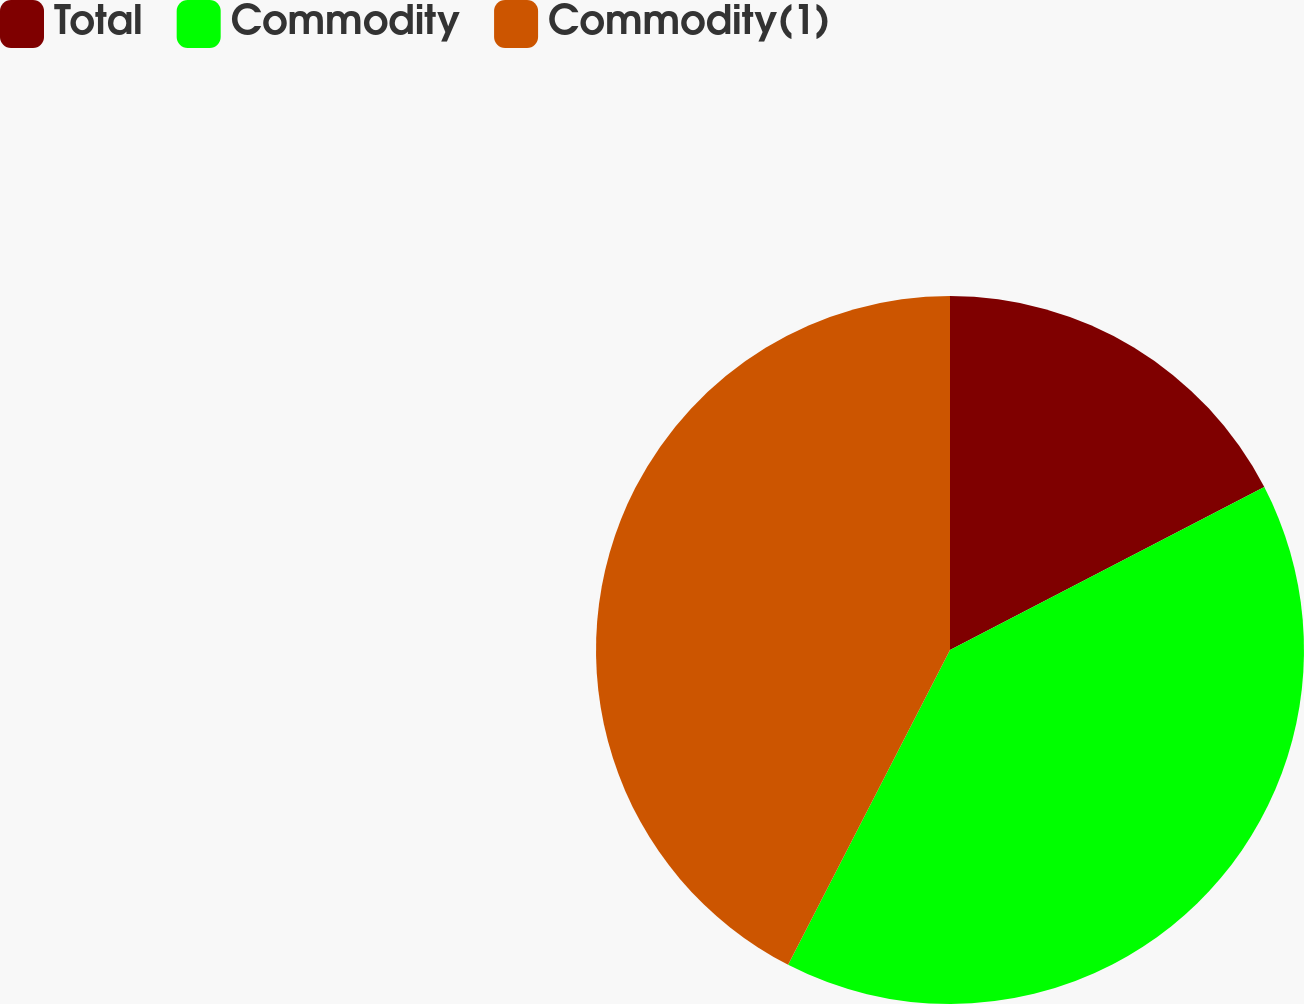<chart> <loc_0><loc_0><loc_500><loc_500><pie_chart><fcel>Total<fcel>Commodity<fcel>Commodity(1)<nl><fcel>17.39%<fcel>40.17%<fcel>42.44%<nl></chart> 